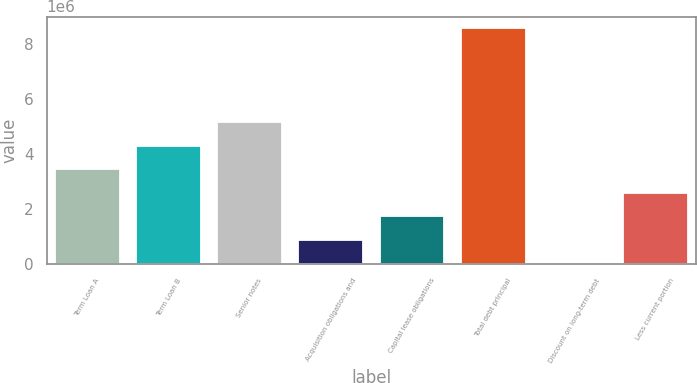Convert chart. <chart><loc_0><loc_0><loc_500><loc_500><bar_chart><fcel>Term Loan A<fcel>Term Loan B<fcel>Senior notes<fcel>Acquisition obligations and<fcel>Capital lease obligations<fcel>Total debt principal<fcel>Discount on long-term debt<fcel>Less current portion<nl><fcel>3.44328e+06<fcel>4.29871e+06<fcel>5.15414e+06<fcel>876978<fcel>1.73241e+06<fcel>8.57587e+06<fcel>21545<fcel>2.58784e+06<nl></chart> 